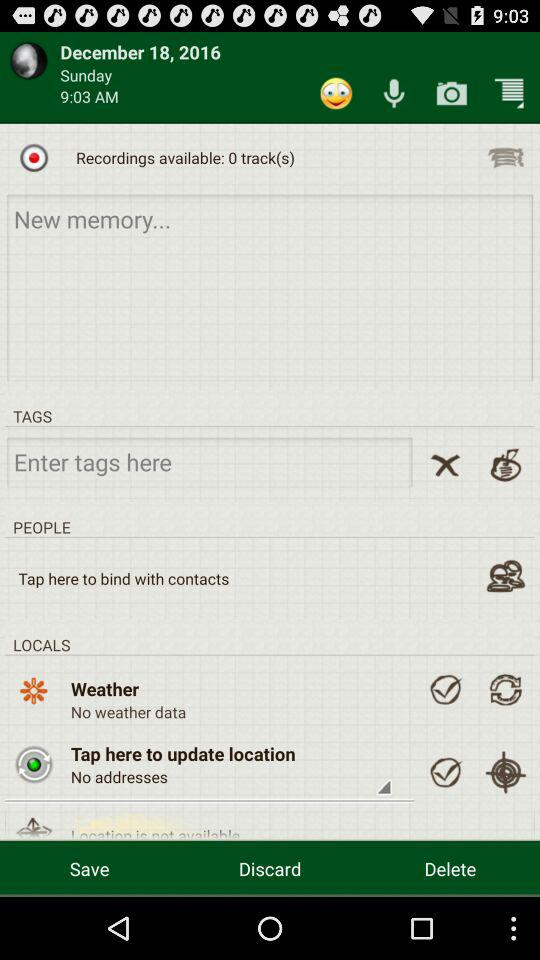What is the date? The date is Sunday, December 18, 2016. 